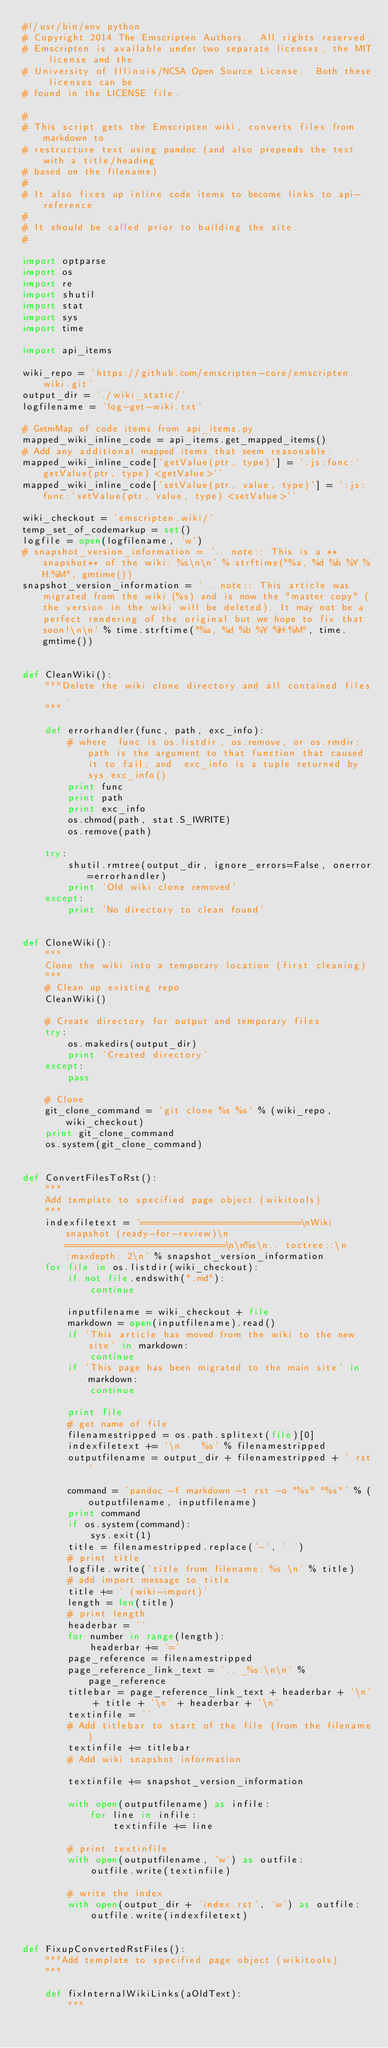Convert code to text. <code><loc_0><loc_0><loc_500><loc_500><_Python_>#!/usr/bin/env python
# Copyright 2014 The Emscripten Authors.  All rights reserved.
# Emscripten is available under two separate licenses, the MIT license and the
# University of Illinois/NCSA Open Source License.  Both these licenses can be
# found in the LICENSE file.

#
# This script gets the Emscripten wiki, converts files from markdown to
# restructure text using pandoc (and also prepends the text with a title/heading
# based on the filename)
#
# It also fixes up inline code items to become links to api-reference
#
# It should be called prior to building the site.
#

import optparse
import os
import re
import shutil
import stat
import sys
import time

import api_items

wiki_repo = 'https://github.com/emscripten-core/emscripten.wiki.git'
output_dir = './wiki_static/'
logfilename = 'log-get-wiki.txt'

# GetmMap of code items from api_items.py
mapped_wiki_inline_code = api_items.get_mapped_items()
# Add any additional mapped items that seem reasonable.
mapped_wiki_inline_code['getValue(ptr, type)'] = ':js:func:`getValue(ptr, type) <getValue>`'
mapped_wiki_inline_code['setValue(ptr, value, type)'] = ':js:func:`setValue(ptr, value, type) <setValue>`'

wiki_checkout = 'emscripten.wiki/'
temp_set_of_codemarkup = set()
logfile = open(logfilename, 'w')
# snapshot_version_information = '.. note:: This is a **snapshot** of the wiki: %s\n\n' % strftime("%a, %d %b %Y %H:%M", gmtime())
snapshot_version_information = '.. note:: This article was migrated from the wiki (%s) and is now the "master copy" (the version in the wiki will be deleted). It may not be a perfect rendering of the original but we hope to fix that soon!\n\n' % time.strftime("%a, %d %b %Y %H:%M", time.gmtime())


def CleanWiki():
    """Delete the wiki clone directory and all contained files.
    """

    def errorhandler(func, path, exc_info):
        # where  func is os.listdir, os.remove, or os.rmdir; path is the argument to that function that caused it to fail; and  exc_info is a tuple returned by  sys.exc_info()
        print func
        print path
        print exc_info
        os.chmod(path, stat.S_IWRITE)
        os.remove(path)

    try:
        shutil.rmtree(output_dir, ignore_errors=False, onerror=errorhandler)
        print 'Old wiki clone removed'
    except:
        print 'No directory to clean found'


def CloneWiki():
    """
    Clone the wiki into a temporary location (first cleaning)
    """
    # Clean up existing repo
    CleanWiki()

    # Create directory for output and temporary files
    try:
        os.makedirs(output_dir)
        print 'Created directory'
    except:
        pass

    # Clone
    git_clone_command = 'git clone %s %s' % (wiki_repo, wiki_checkout)
    print git_clone_command
    os.system(git_clone_command)


def ConvertFilesToRst():
    """
    Add template to specified page object (wikitools)
    """
    indexfiletext = '============================\nWiki snapshot (ready-for-review)\n============================\n\n%s\n.. toctree::\n    :maxdepth: 2\n' % snapshot_version_information
    for file in os.listdir(wiki_checkout):
        if not file.endswith(".md"):
            continue

        inputfilename = wiki_checkout + file
        markdown = open(inputfilename).read()
        if 'This article has moved from the wiki to the new site' in markdown:
            continue
        if 'This page has been migrated to the main site' in markdown:
            continue

        print file
        # get name of file
        filenamestripped = os.path.splitext(file)[0]
        indexfiletext += '\n    %s' % filenamestripped
        outputfilename = output_dir + filenamestripped + '.rst'

        command = 'pandoc -f markdown -t rst -o "%s" "%s"' % (outputfilename, inputfilename)
        print command
        if os.system(command):
            sys.exit(1)
        title = filenamestripped.replace('-', ' ')
        # print title
        logfile.write('title from filename: %s \n' % title)
        # add import message to title
        title += ' (wiki-import)'
        length = len(title)
        # print length
        headerbar = ''
        for number in range(length):
            headerbar += '='
        page_reference = filenamestripped
        page_reference_link_text = '.. _%s:\n\n' % page_reference
        titlebar = page_reference_link_text + headerbar + '\n' + title + '\n' + headerbar + '\n'
        textinfile = ''
        # Add titlebar to start of the file (from the filename)
        textinfile += titlebar
        # Add wiki snapshot information

        textinfile += snapshot_version_information

        with open(outputfilename) as infile:
            for line in infile:
                textinfile += line

        # print textinfile
        with open(outputfilename, 'w') as outfile:
            outfile.write(textinfile)

        # write the index
        with open(output_dir + 'index.rst', 'w') as outfile:
            outfile.write(indexfiletext)


def FixupConvertedRstFiles():
    """Add template to specified page object (wikitools)
    """

    def fixInternalWikiLinks(aOldText):
        """</code> 